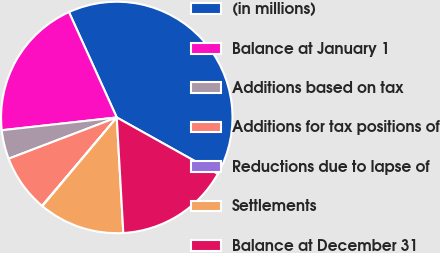Convert chart. <chart><loc_0><loc_0><loc_500><loc_500><pie_chart><fcel>(in millions)<fcel>Balance at January 1<fcel>Additions based on tax<fcel>Additions for tax positions of<fcel>Reductions due to lapse of<fcel>Settlements<fcel>Balance at December 31<nl><fcel>39.89%<fcel>19.98%<fcel>4.04%<fcel>8.03%<fcel>0.06%<fcel>12.01%<fcel>15.99%<nl></chart> 